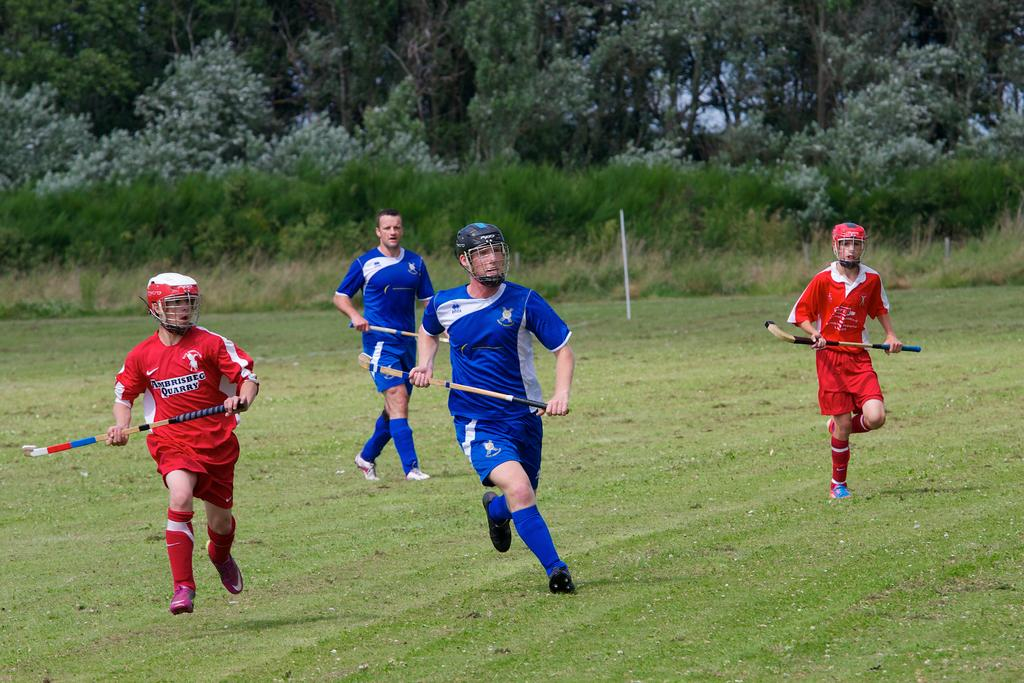Who or what can be seen in the image? There are people in the image. What are the people doing? The people are running. What objects are the people holding in their hands? The people are holding bats in their hands. What can be seen in the background of the image? There are trees and grass in the background of the image. What type of apparel are the people wearing in the image? The provided facts do not mention any specific apparel worn by the people in the image. 